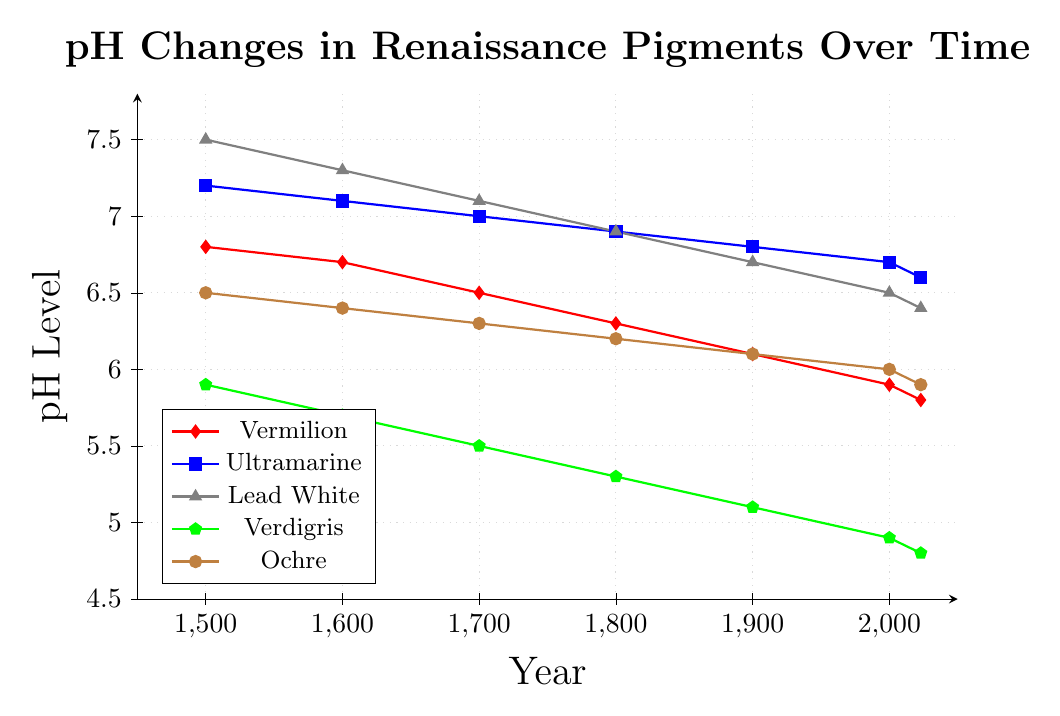What is the pH level of Ultramarine in the year 1500? The figure has a blue line with square markers representing Ultramarine. Looking at the point in 1500, it shows the pH is 7.2.
Answer: 7.2 Which pigment shows the greatest pH decline from 1500 to 2023? Checking each pigment's pH in 1500 and 2023: Vermilion declines from 6.8 to 5.8, Ultramarine from 7.2 to 6.6, Lead White from 7.5 to 6.4, Verdigris from 5.9 to 4.8, Ochre from 6.5 to 5.9. Lead White shows the greatest decline of 7.5 − 6.4 = 1.1.
Answer: Lead White Between 1500 and 1600, which pigment experienced the smallest decrease in pH levels? Comparing the pH values: Vermilion (6.8 to 6.7), Ultramarine (7.2 to 7.1), Lead white (7.5 to 7.3), Verdigris (5.9 to 5.7), Ochre (6.5 to 6.4). The smallest decrease is 0.1 for Ochre.
Answer: Ochre What is the overall trend for the pH level of Verdigris over the centuries? The Verdigris pH trend (green line) from 1500 to 2023 is always decreasing: 5.9 in 1500, 5.7 in 1600, 5.5 in 1700, 5.3 in 1800, 5.1 in 1900, 4.9 in 2000, and 4.8 in 2023.
Answer: Decreasing What is the average pH level of Ochre across the recorded years? Adding up Ochre’s pH numbers from 1500, 1600, 1700, 1800, 1900, 2000, 2023, then dividing by the total number of time points: (6.5 + 6.4 + 6.3 + 6.2 + 6.1 + 6.0 + 5.9) / 7 = 6.20.
Answer: 6.20 How does the pH level of Vermilion in 2000 compare to that of Lead White in 1800? The pH of Vermilion in 2000 is 5.9, and the pH of Lead White in 1800 is 6.9. Thus, Vermilion in 2000 is lower than Lead White in 1800.
Answer: Lower Calculate the difference between the pH levels of Ultramarine and Verdigris in 2023. For Ultramarine in 2023, pH is 6.6, and for Verdigris, pH is 4.8. The difference is 6.6 − 4.8 = 1.8.
Answer: 1.8 Which pigment had the highest pH level in the year 1800? By checking each pigment's pH level in 1800: Vermilion (6.3), Ultramarine (6.9), Lead White (6.9), Verdigris (5.3), and Ochre (6.2). Ultramarine and Lead White both have the highest pH of 6.9.
Answer: Ultramarine and Lead White How does the pH change rate for Vermilion compare to that of Ochre from 1500 to 2023? Vermilion’s pH changed from 6.8 to 5.8, a difference of 1.0 over 523 years. Ochre changed from 6.5 to 5.9, a difference of 0.6. Vermilion had a faster rate of change.
Answer: Vermilion faster What is the median pH level of Lead White across all recorded years? Listing Lead White levels from smallest to largest: 6.4, 6.5, 6.7, 6.9, 7.1, 7.3, 7.5. The middle value, or median, is 6.9.
Answer: 6.9 